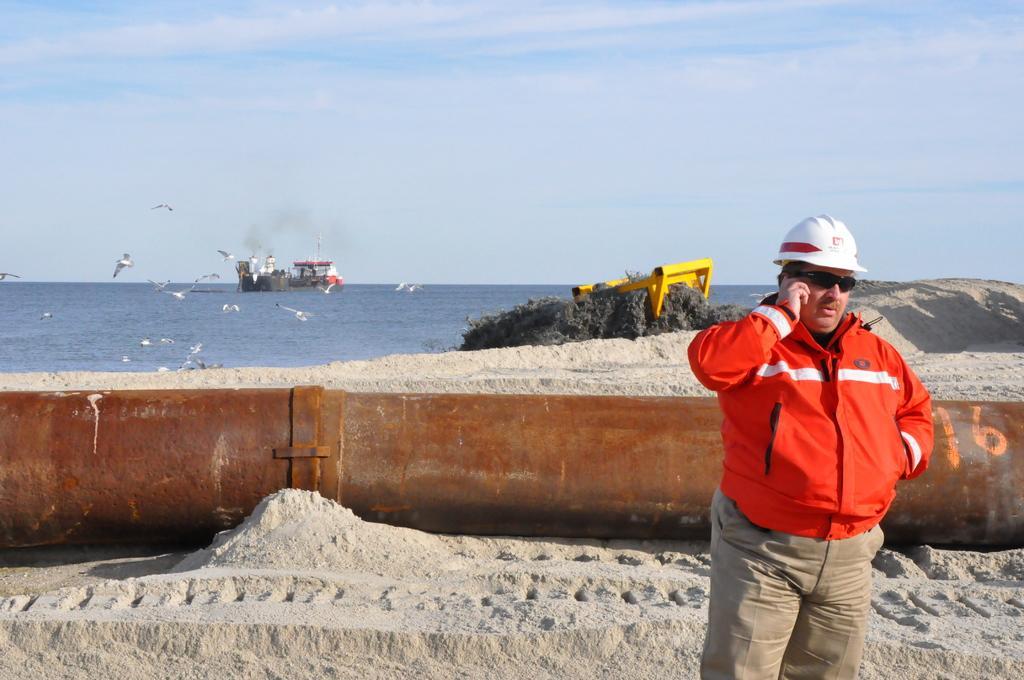Can you describe this image briefly? In this image there is one person standing and holding a mobile on the right side of this image, and there is a wall in middle of this image and there is a sea on top side to this wall , and there are two boats as we can see on the left side of this image and there are some birds on the left side to this boat. There is a sky on the top of this image. There is a soil ground on the bottom of this image and middle of this image as well. 